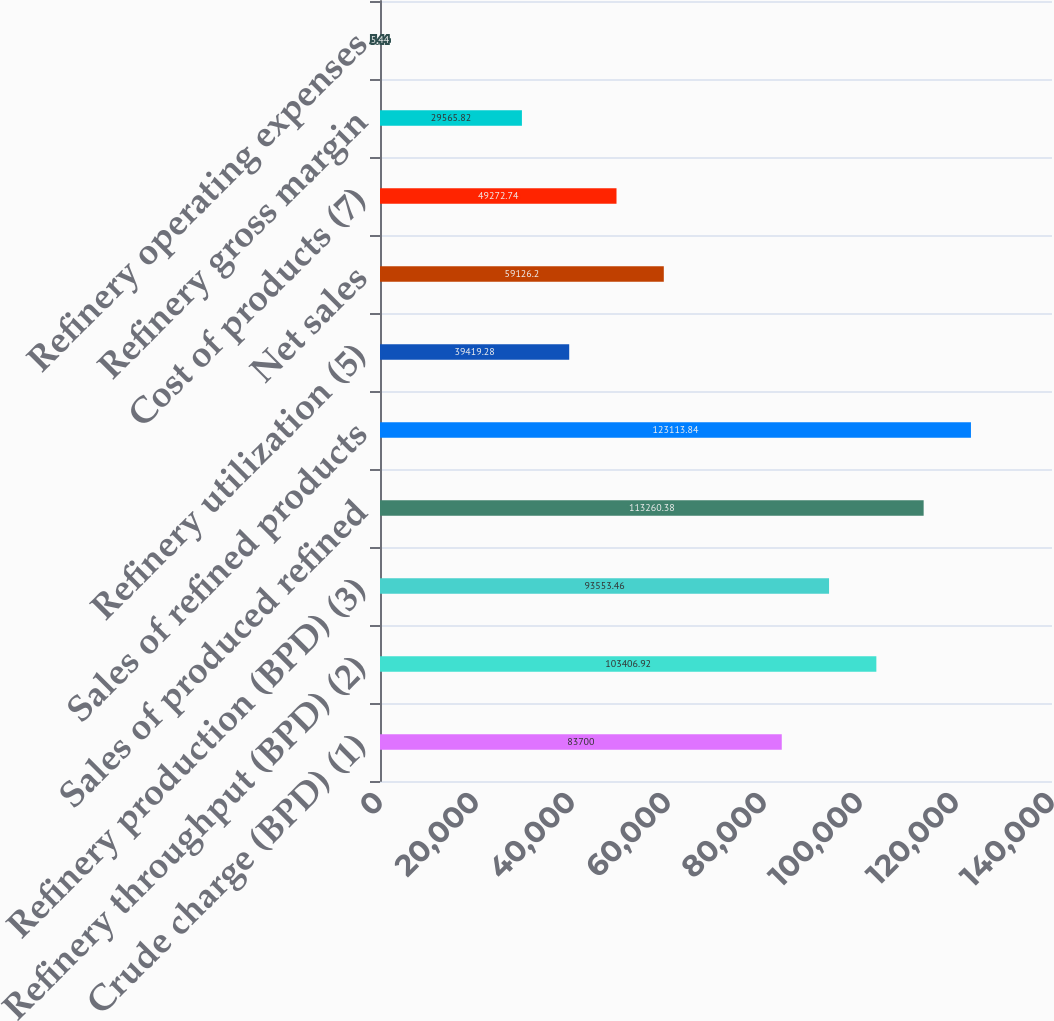Convert chart to OTSL. <chart><loc_0><loc_0><loc_500><loc_500><bar_chart><fcel>Crude charge (BPD) (1)<fcel>Refinery throughput (BPD) (2)<fcel>Refinery production (BPD) (3)<fcel>Sales of produced refined<fcel>Sales of refined products<fcel>Refinery utilization (5)<fcel>Net sales<fcel>Cost of products (7)<fcel>Refinery gross margin<fcel>Refinery operating expenses<nl><fcel>83700<fcel>103407<fcel>93553.5<fcel>113260<fcel>123114<fcel>39419.3<fcel>59126.2<fcel>49272.7<fcel>29565.8<fcel>5.44<nl></chart> 